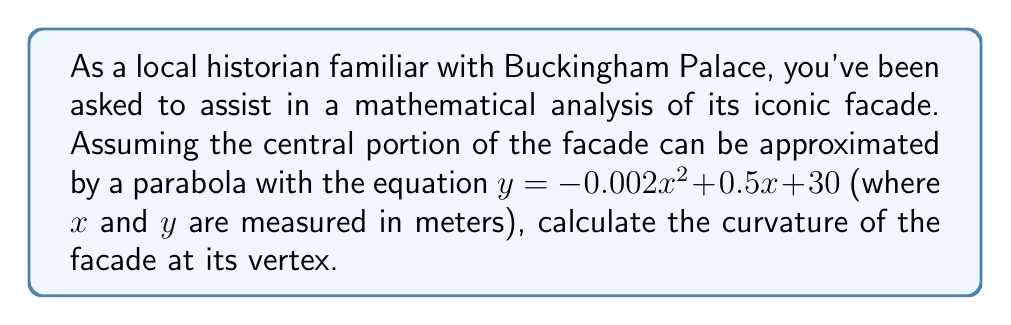Solve this math problem. To calculate the curvature of the facade at its vertex, we'll follow these steps:

1) The general formula for the curvature of a curve $y = f(x)$ at any point is:

   $$\kappa = \frac{|f''(x)|}{(1 + (f'(x))^2)^{3/2}}$$

2) For a parabola $y = ax^2 + bx + c$, the vertex occurs at $x = -\frac{b}{2a}$. In our case:
   $a = -0.002$, $b = 0.5$, $c = 30$
   
   So, the vertex is at $x = -\frac{0.5}{2(-0.002)} = 125$ meters

3) We need to find $f'(x)$ and $f''(x)$:
   $f'(x) = -0.004x + 0.5$
   $f''(x) = -0.004$

4) At the vertex $(x = 125)$:
   $f'(125) = -0.004(125) + 0.5 = 0$
   $f''(125) = -0.004$

5) Substituting into the curvature formula:

   $$\kappa = \frac{|-0.004|}{(1 + (0)^2)^{3/2}} = 0.004$$

Therefore, the curvature of the facade at its vertex is 0.004 m^(-1).
Answer: $0.004$ m^(-1) 